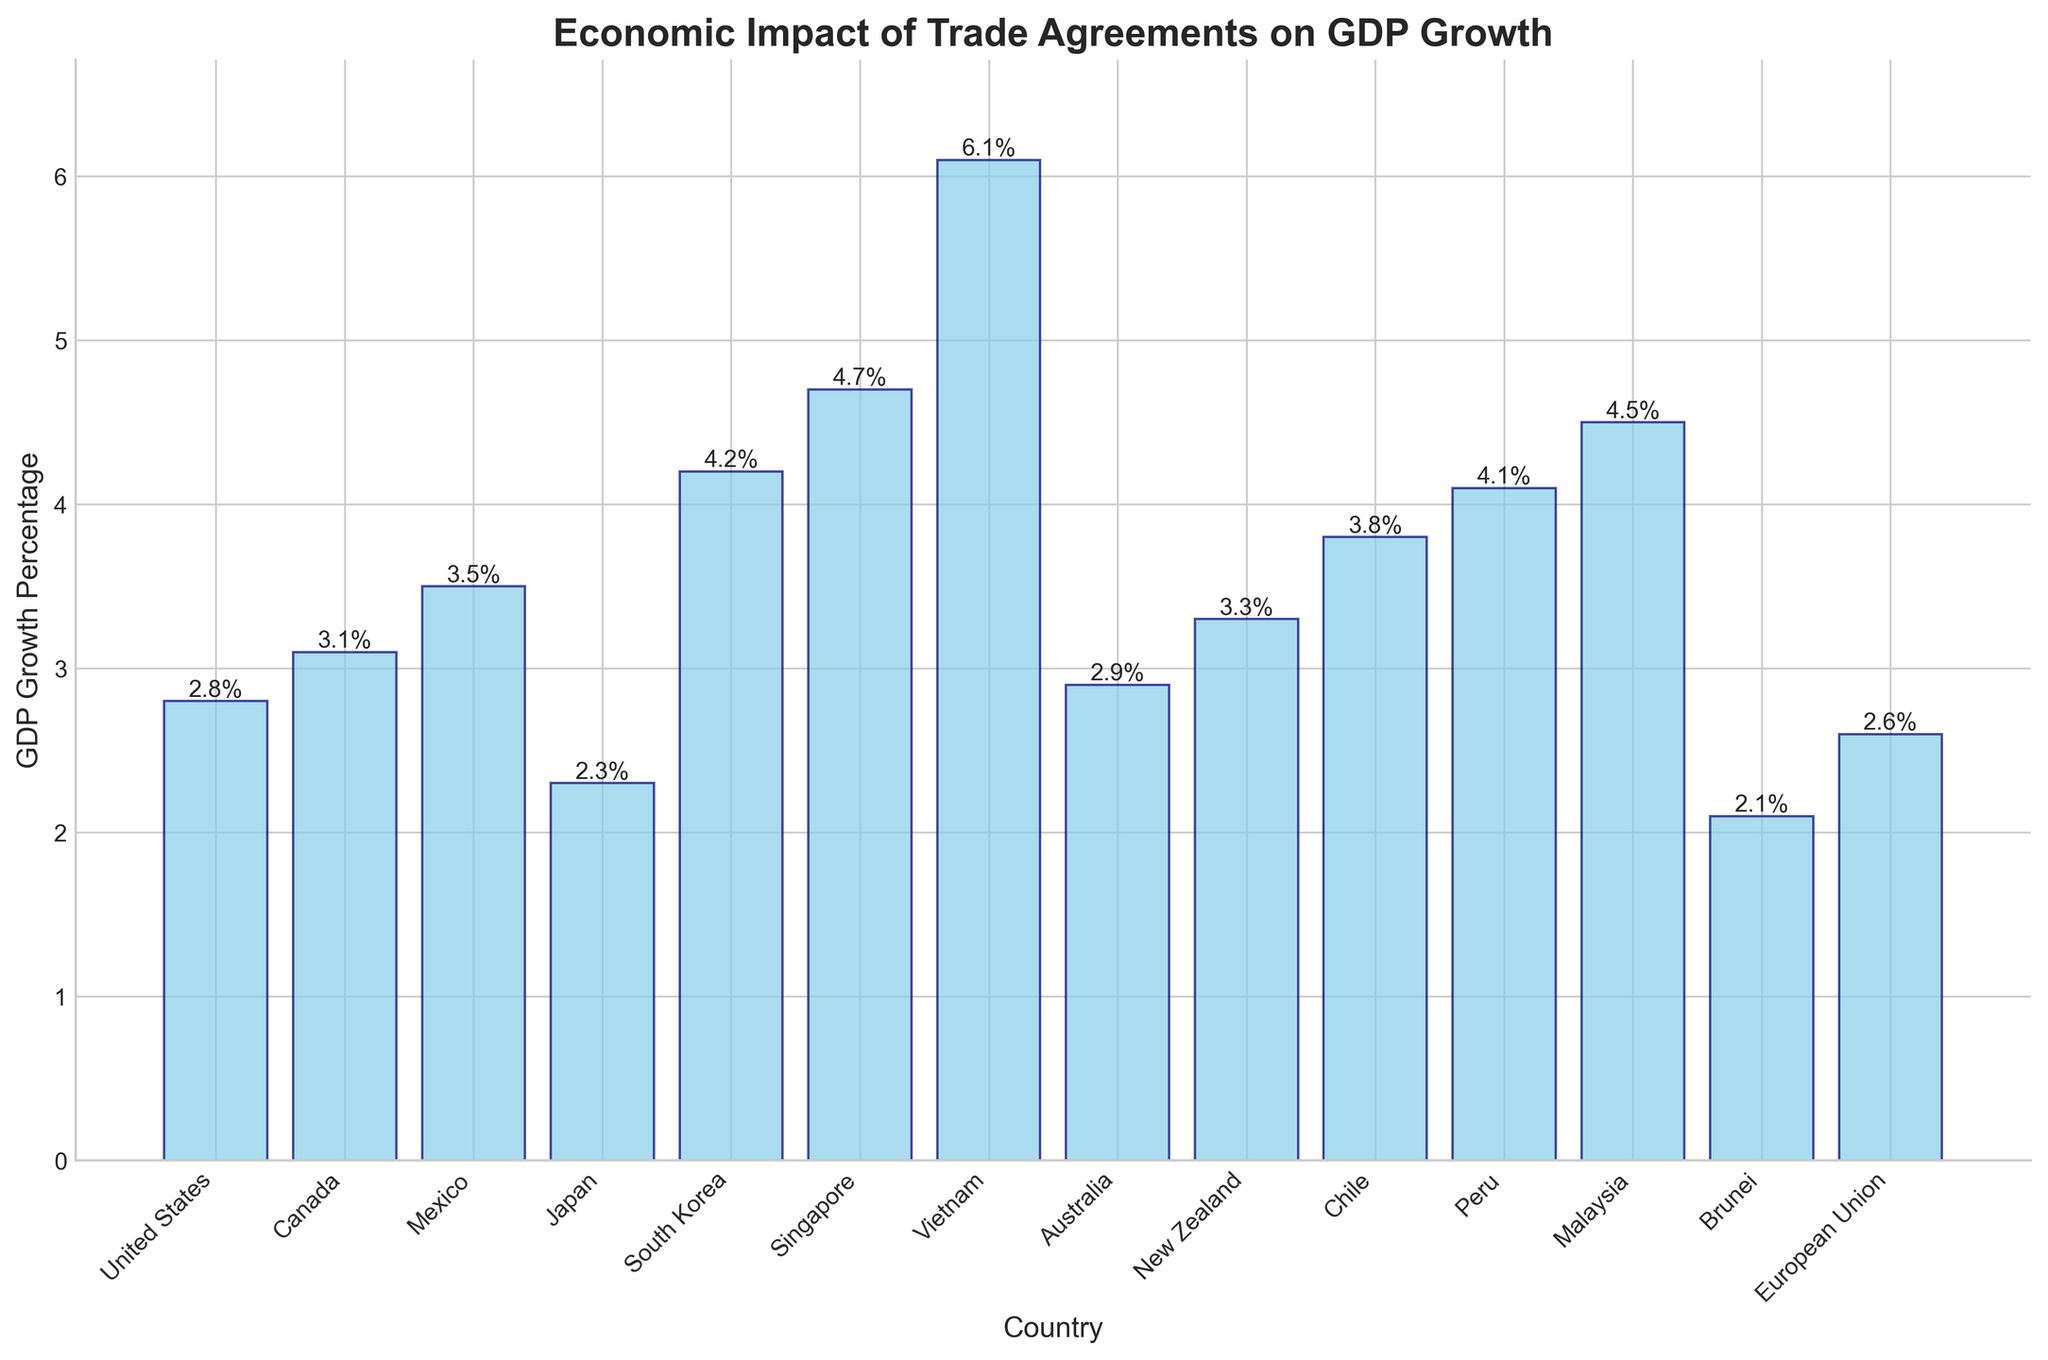Which country experienced the highest GDP growth percentage after the trade agreement? The bar chart shows the height of each bar corresponding to the GDP growth percentage of the countries listed. The highest bar represents Vietnam's 6.1% GDP growth.
Answer: Vietnam Which country experienced the lowest GDP growth percentage after the trade agreement? The bar chart shows the height of each bar corresponding to the GDP growth percentage of the countries listed. The shortest bar represents Brunei's 2.1% GDP growth.
Answer: Brunei How much more did Singapore's GDP grow compared to Japan's after the trade agreement? From the bar chart, Singapore's GDP growth is 4.7% and Japan's is 2.3%. The difference is 4.7 - 2.3 = 2.4%.
Answer: 2.4% Which country has a GDP growth percentage between 3% and 4% after the trade agreement? The bar chart shows multiple countries fall in this range: Canada (3.1%), New Zealand (3.3%), Chile (3.8%).
Answer: Canada, New Zealand, Chile What is the average GDP growth percentage across all the countries after the trade agreement? Add up all the GDP growth percentages and divide by the number of countries: (2.8 + 3.1 + 3.5 + 2.3 + 4.2 + 4.7 + 6.1 + 2.9 + 3.3 + 3.8 + 4.1 + 4.5 + 2.1 + 2.6) / 14 = 3.59%
Answer: 3.59% How does the GDP growth percentage of South Korea compare to that of Peru? The bar chart shows South Korea's GDP growth is 4.2% while Peru's GDP growth is 4.1%. South Korea's GDP growth is slightly higher.
Answer: South Korea > Peru Which countries have a GDP growth percentage greater than 4%? The bar chart shows the following countries with GDP growth percentages greater than 4%: South Korea (4.2%), Singapore (4.7%), Vietnam (6.1%), Peru (4.1%), Malaysia (4.5%).
Answer: South Korea, Singapore, Vietnam, Peru, Malaysia Is the GDP growth percentage of the European Union higher than that of Australia? The bar chart shows the European Union's GDP growth percentage is 2.6% and Australia's is 2.9%. Australia's GDP growth is higher.
Answer: No What is the total GDP growth percentage of North American countries (United States, Canada, Mexico) after the trade agreement? Add the GDP growth percentages of the United States (2.8%), Canada (3.1%), and Mexico (3.5%): 2.8 + 3.1 + 3.5 = 9.4%.
Answer: 9.4% What is the median GDP growth percentage among all the countries? Arrange the GDP growth percentages in ascending order and find the middle value(s): [2.1, 2.3, 2.6, 2.8, 2.9, 3.1, 3.3, 3.5, 3.8, 4.1, 4.2, 4.5, 4.7, 6.1]. The two middle values are 3.3 and 3.5, so the median is (3.3 + 3.5) / 2 = 3.4%.
Answer: 3.4% 